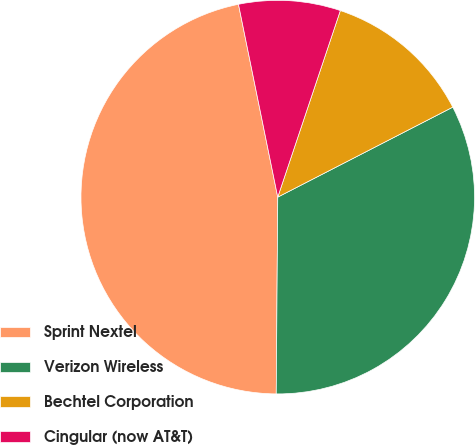<chart> <loc_0><loc_0><loc_500><loc_500><pie_chart><fcel>Sprint Nextel<fcel>Verizon Wireless<fcel>Bechtel Corporation<fcel>Cingular (now AT&T)<nl><fcel>46.68%<fcel>32.68%<fcel>12.29%<fcel>8.35%<nl></chart> 